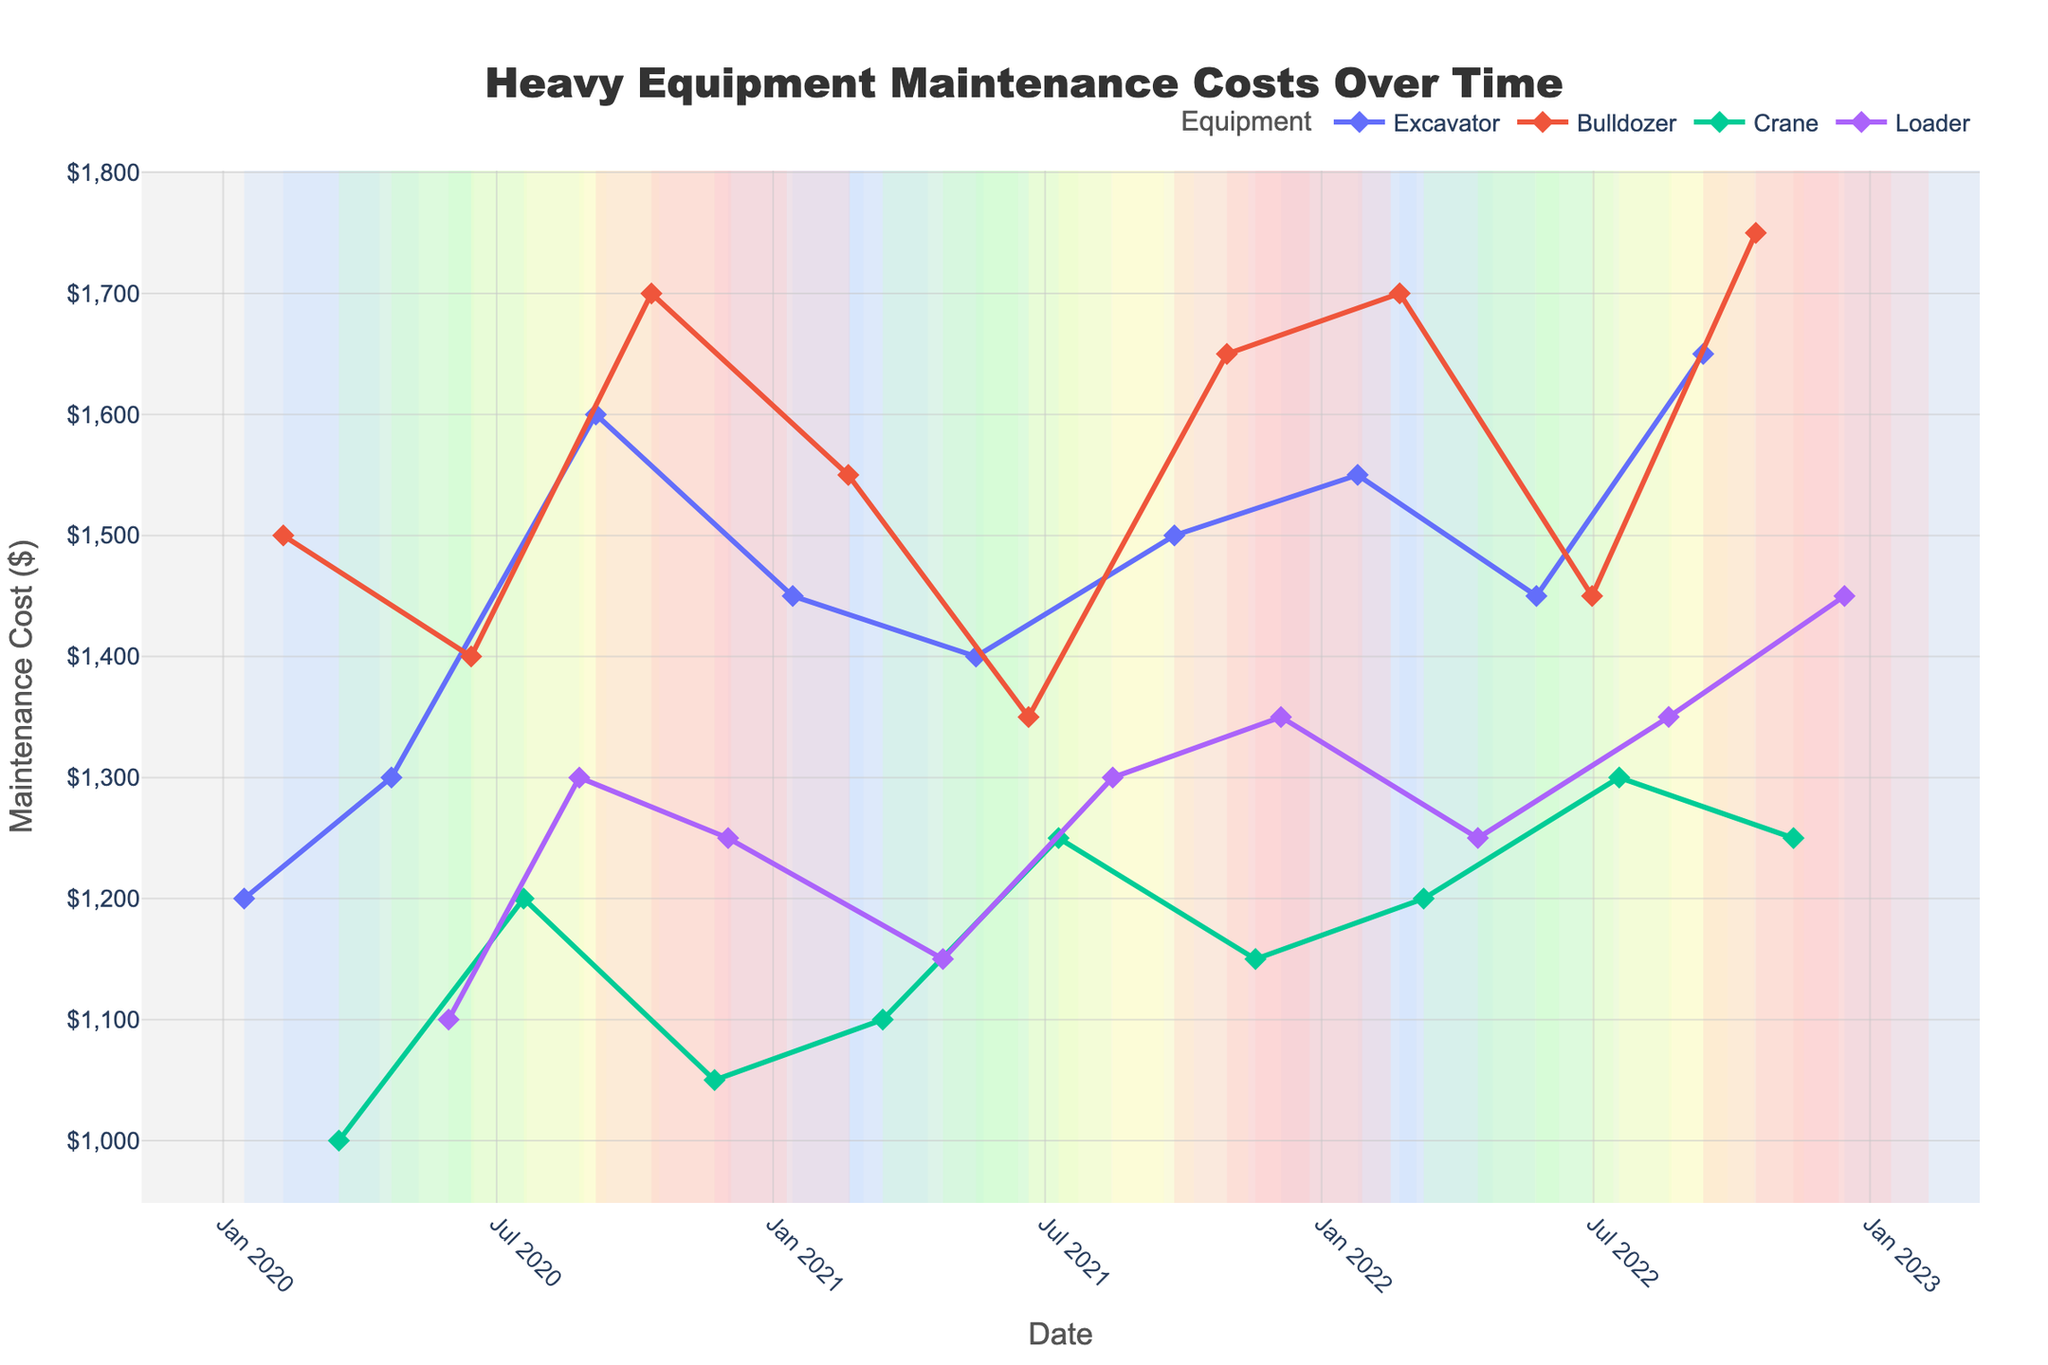What's the title of the figure? The title is prominently displayed at the top center of the figure. It provides a summary of what the plot is about.
Answer: Heavy Equipment Maintenance Costs Over Time What are the Seasonal Background Colors used in the figure? The background colors demarcate different seasons. Winter uses a bluish color, Spring uses a greenish color, Summer uses a yellowish color, and Autumn uses a reddish color.
Answer: Bluish for Winter, Greenish for Spring, Yellowish for Summer, Reddish for Autumn How does the maintenance cost for the Bulldozer change from Winter 2020 to Winter 2022? From the figure, we can see the maintenance costs for the Bulldozer increasing across the winters. In Winter 2020, it starts at $1500, then $1550 in Winter 2021, and $1700 in Winter 2022.
Answer: It increased What is the highest maintenance cost recorded in the data and during which season? By examining the highest points on the y-axis and identifying their corresponding dates and seasons, we can see that the highest maintenance cost is $1750 in Autumn 2022 for the Bulldozer.
Answer: $1750, Autumn 2022 Which equipment had the highest maintenance cost in Summer 2022, and what was the cost? To find this, look at all data points in Summer 2022 and compare the costs. The Loader had the highest maintenance cost in Summer 2022 with a cost of $1350.
Answer: Loader, $1350 Compare the maintenance costs of the Excavator and Crane in Spring 2022. Which one is higher? In Spring 2022, the Excavator's maintenance cost is $1450, while the Crane's maintenance cost is $1200. Comparing these values shows that the Excavator has the higher maintenance cost.
Answer: Excavator Which equipment had a consistent maintenance cost in Summer for all three years? We can identify this by observing the lines for all Summers. The Loader consistently shows $1300 during Summer for all three years.
Answer: Loader What trends can you observe in the seasonal maintenance costs for the Excavator over the three-year period? Over the three-year period, the maintenance cost for the Excavator generally increases every season. It starts lower in 2020 and reaches its peak by Autumn 2022.
Answer: General increase How does the maintenance cost for the Loader change from Spring 2020 to Spring 2022? Comparing these two points, the cost starts at $1100 in Spring 2020 and increases to $1250 in Spring 2022, showing an increasing trend.
Answer: It increased Which season generally has the highest maintenance costs across all equipment types? By comparing the costs in each season shown by the background colors, we see that Autumn generally has higher maintenance costs across the equipment types.
Answer: Autumn 